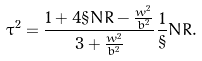Convert formula to latex. <formula><loc_0><loc_0><loc_500><loc_500>\tau ^ { 2 } = \frac { 1 + 4 \S N R - \frac { w ^ { 2 } } { b ^ { 2 } } } { 3 + \frac { w ^ { 2 } } { b ^ { 2 } } } \frac { 1 } { \S } N R .</formula> 